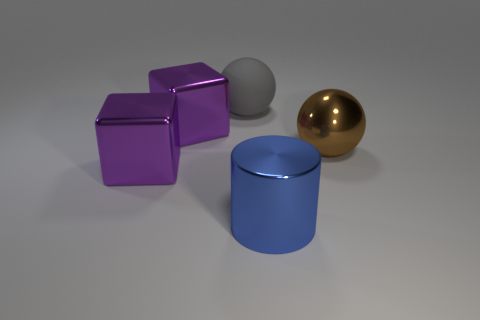How many large balls are both in front of the big gray ball and left of the brown shiny ball?
Ensure brevity in your answer.  0. Are the big ball that is on the left side of the large blue shiny cylinder and the big brown object made of the same material?
Your response must be concise. No. The object that is in front of the shiny cube in front of the shiny thing on the right side of the blue object is what shape?
Offer a terse response. Cylinder. Are there the same number of brown things that are left of the large brown metal thing and large metal cylinders that are left of the blue cylinder?
Keep it short and to the point. Yes. What is the color of the other sphere that is the same size as the rubber sphere?
Provide a succinct answer. Brown. What number of small things are either rubber spheres or blue metallic cylinders?
Give a very brief answer. 0. There is a large thing that is behind the metallic ball and on the left side of the gray thing; what is its material?
Provide a short and direct response. Metal. There is a big shiny object on the right side of the blue cylinder; is its shape the same as the big matte thing on the left side of the large blue object?
Make the answer very short. Yes. How many objects are large things in front of the rubber sphere or large purple shiny things?
Ensure brevity in your answer.  4. Is the blue object the same size as the gray sphere?
Your answer should be very brief. Yes. 